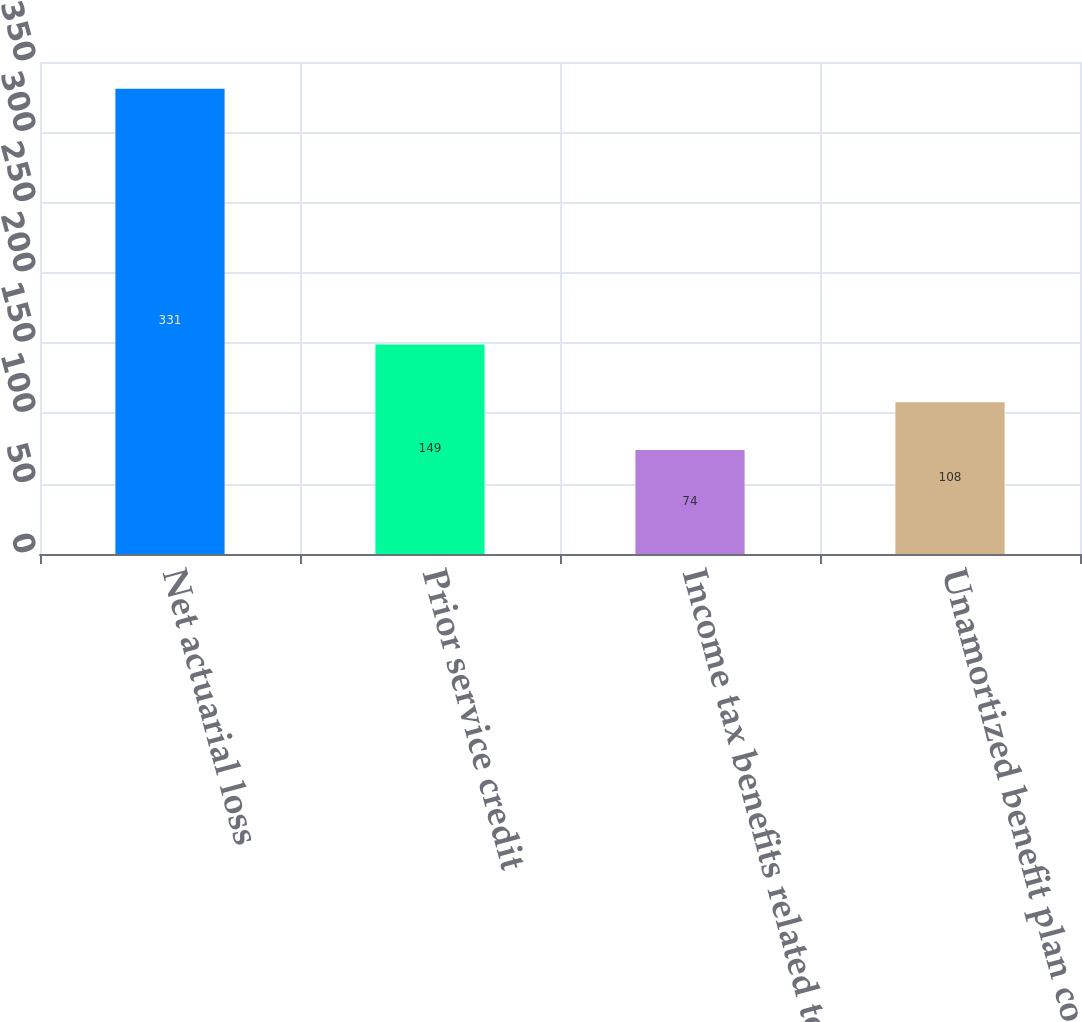<chart> <loc_0><loc_0><loc_500><loc_500><bar_chart><fcel>Net actuarial loss<fcel>Prior service credit<fcel>Income tax benefits related to<fcel>Unamortized benefit plan costs<nl><fcel>331<fcel>149<fcel>74<fcel>108<nl></chart> 